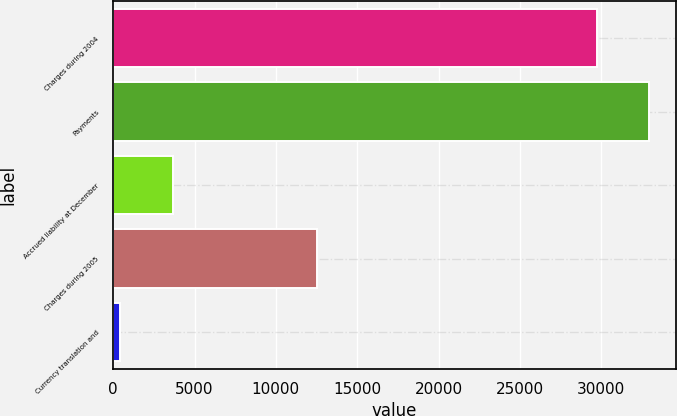Convert chart. <chart><loc_0><loc_0><loc_500><loc_500><bar_chart><fcel>Charges during 2004<fcel>Payments<fcel>Accrued liability at December<fcel>Charges during 2005<fcel>Currency translation and<nl><fcel>29707<fcel>32939.7<fcel>3664.7<fcel>12500.7<fcel>432<nl></chart> 